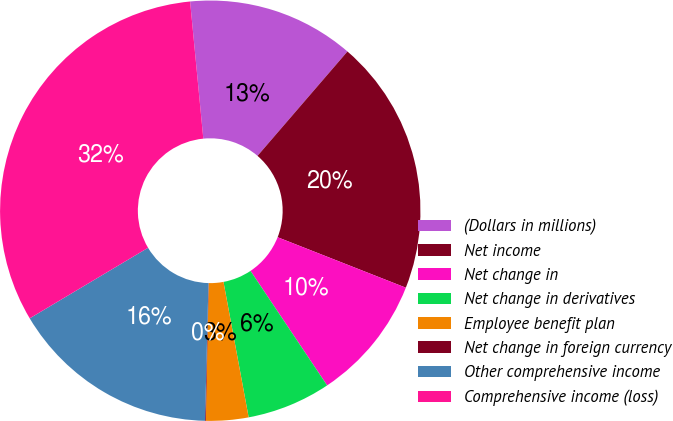<chart> <loc_0><loc_0><loc_500><loc_500><pie_chart><fcel>(Dollars in millions)<fcel>Net income<fcel>Net change in<fcel>Net change in derivatives<fcel>Employee benefit plan<fcel>Net change in foreign currency<fcel>Other comprehensive income<fcel>Comprehensive income (loss)<nl><fcel>12.85%<fcel>19.65%<fcel>9.65%<fcel>6.46%<fcel>3.26%<fcel>0.06%<fcel>16.05%<fcel>32.03%<nl></chart> 